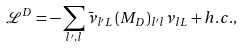Convert formula to latex. <formula><loc_0><loc_0><loc_500><loc_500>\mathcal { L } ^ { D } = - \sum _ { l ^ { \prime } , l } \bar { \nu } _ { l ^ { \prime } L } \, ( M _ { D } ) _ { l ^ { \prime } l } \nu _ { l L } + h . c . ,</formula> 